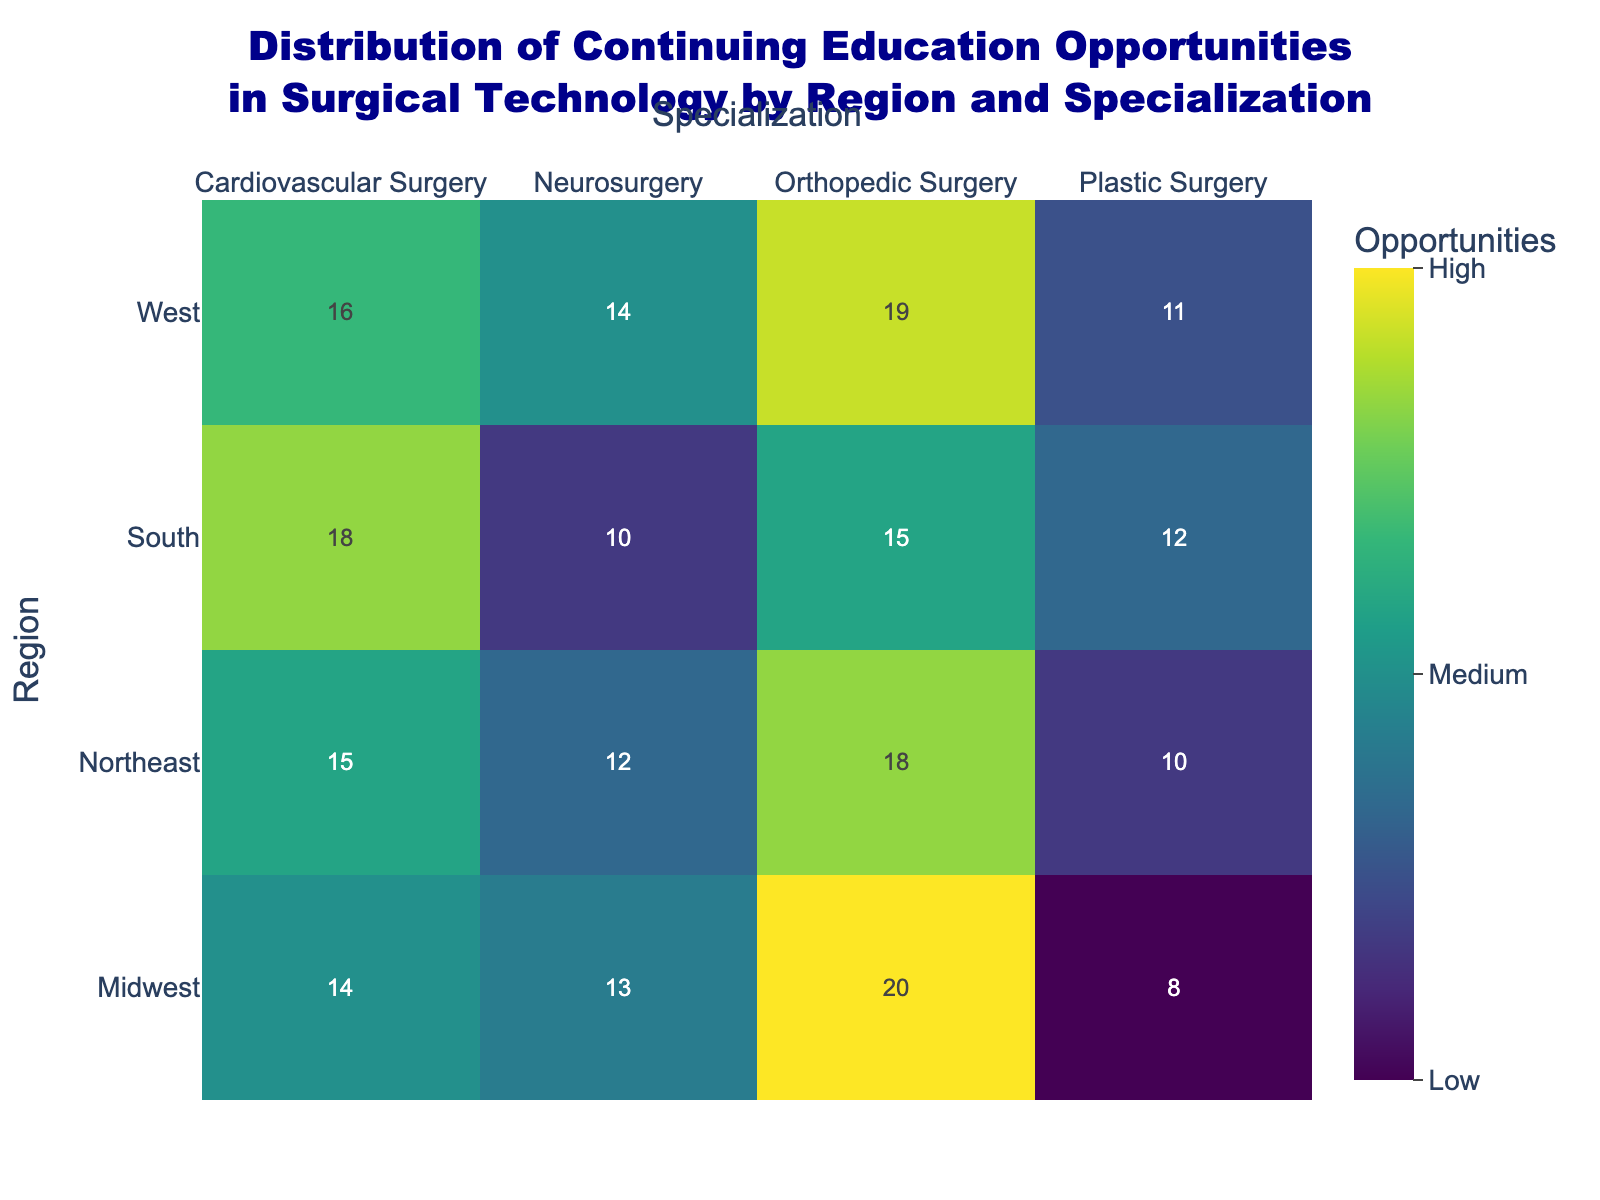Which region has the highest number of continuing education opportunities in Orthopedic Surgery? Look at the Orthopedic Surgery column and identify the highest value and its corresponding region. The values are 18 (Northeast), 20 (Midwest), 15 (South), and 19 (West). The Midwest has the highest value.
Answer: Midwest What's the average number of continuing education opportunities in Neurosurgery across all regions? Add the values for Neurosurgery across all regions: 12 (Northeast), 13 (Midwest), 10 (South), 14 (West). The sum is 49. Divide by the number of regions, 4: 49/4 = 12.25.
Answer: 12.25 Which specialization has the least number of continuing education opportunities in the South? Look at the rows corresponding to the South region and identify the lowest value. The values are 18 (Cardiovascular Surgery), 10 (Neurosurgery), 15 (Orthopedic Surgery), and 12 (Plastic Surgery). Neurosurgery has the least value, 10.
Answer: Neurosurgery Compare the number of continuing education opportunities in Cardiovascular Surgery between the Northeast and West regions. Which region has more opportunities? Compare the values for Cardiovascular Surgery in the Northeast and West: 15 (Northeast) and 16 (West). The West has more opportunities.
Answer: West What is the difference in continuing education opportunities for Plastic Surgery between the Midwest and Northeast regions? Subtract the value of Plastic Surgery in the Northeast from that in the Midwest: 8 (Midwest) - 10 (Northeast) = -2.
Answer: -2 What is the total number of continuing education opportunities across all regions for Cardiovascular Surgery? Add the values for Cardiovascular Surgery across all regions: 15 (Northeast), 14 (Midwest), 18 (South), 16 (West). The sum is 63.
Answer: 63 Which specialization in the West has the highest number of continuing education opportunities? Look at the row corresponding to the West and identify the highest value. The values are 16 (Cardiovascular Surgery), 14 (Neurosurgery), 19 (Orthopedic Surgery), and 11 (Plastic Surgery). Orthopedic Surgery has the highest value, 19.
Answer: Orthopedic Surgery How many specializations have exactly 10 continuing education opportunities in any region? Examine each cell in the heatmap to count how many times the value 10 appears. It appears twice, in Neurosurgery (South) and Plastic Surgery (Northeast).
Answer: 2 